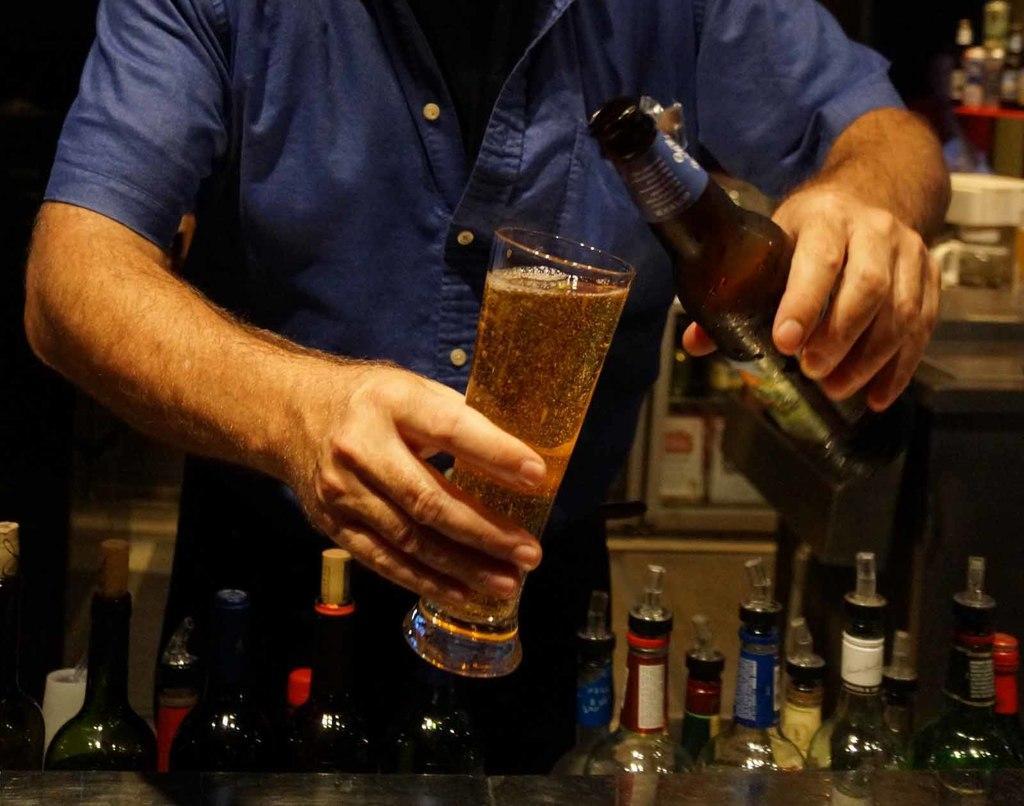Could you give a brief overview of what you see in this image? In the image there is a man wearing a blue color shirt holding a wine glass in one hand and wine bottle in other hand and standing in front of a table, on table we can see some bottles. 